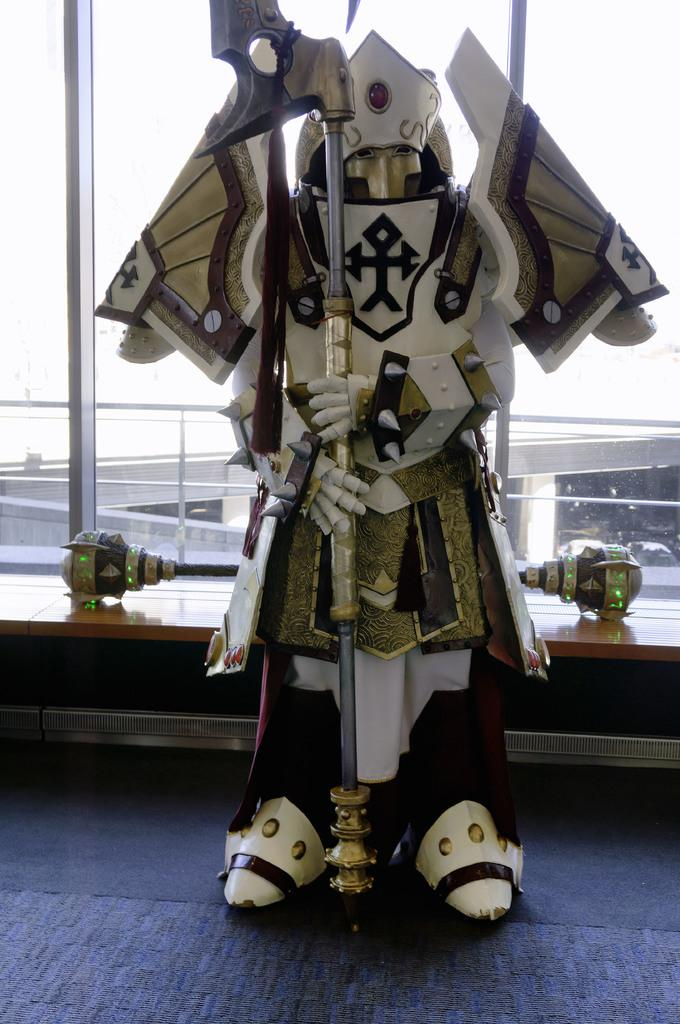What is the main subject of the image? There is a sculpture in the image. Where is the sculpture located? The sculpture is on a surface. What can be seen behind the sculpture? There are objects behind the sculpture. What is visible in the background of the image? There is a bridge, pillars, and vehicles visible in the background of the image. How much has the tree grown since the image was taken? There is no tree present in the image, so it is not possible to determine how much it has grown since the image was taken. 